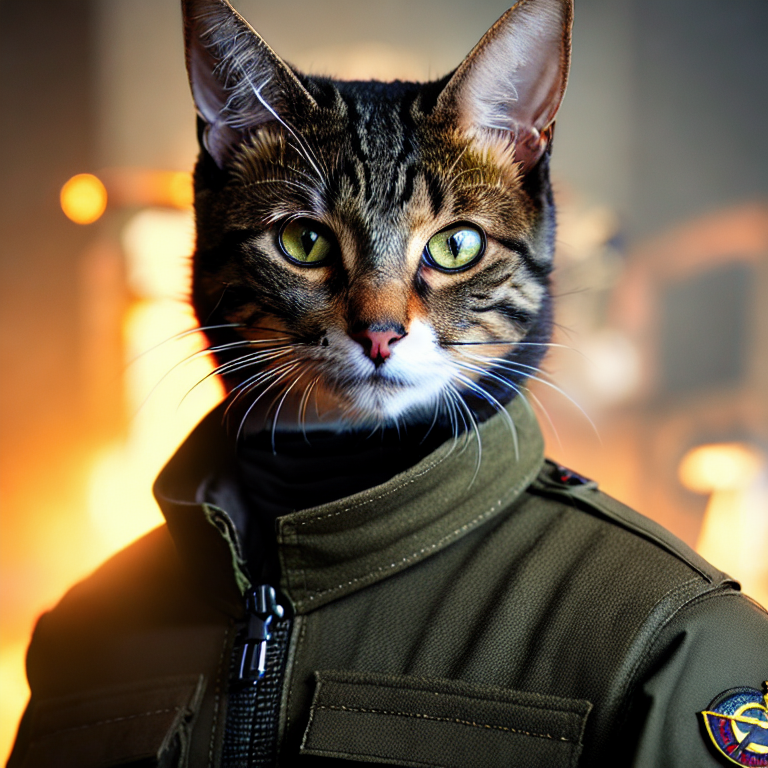Check this image. Can you give me a short description for it? The image depicts an anthropomorphic depiction of a cat, adeptly dressed in a military-style jacket, which suggests themes of leadership and bravery commonly found in action-adventure genres. The jacket is detailed, featuring patches that hint at a fictional military unit, possibly referencing or parodying heroic tales. The cat's expression, combined with its human-like attire, cleverly blends elements of realism and fantasy, inviting viewers to imagine a whimsical world where cats undertake daring adventures. 